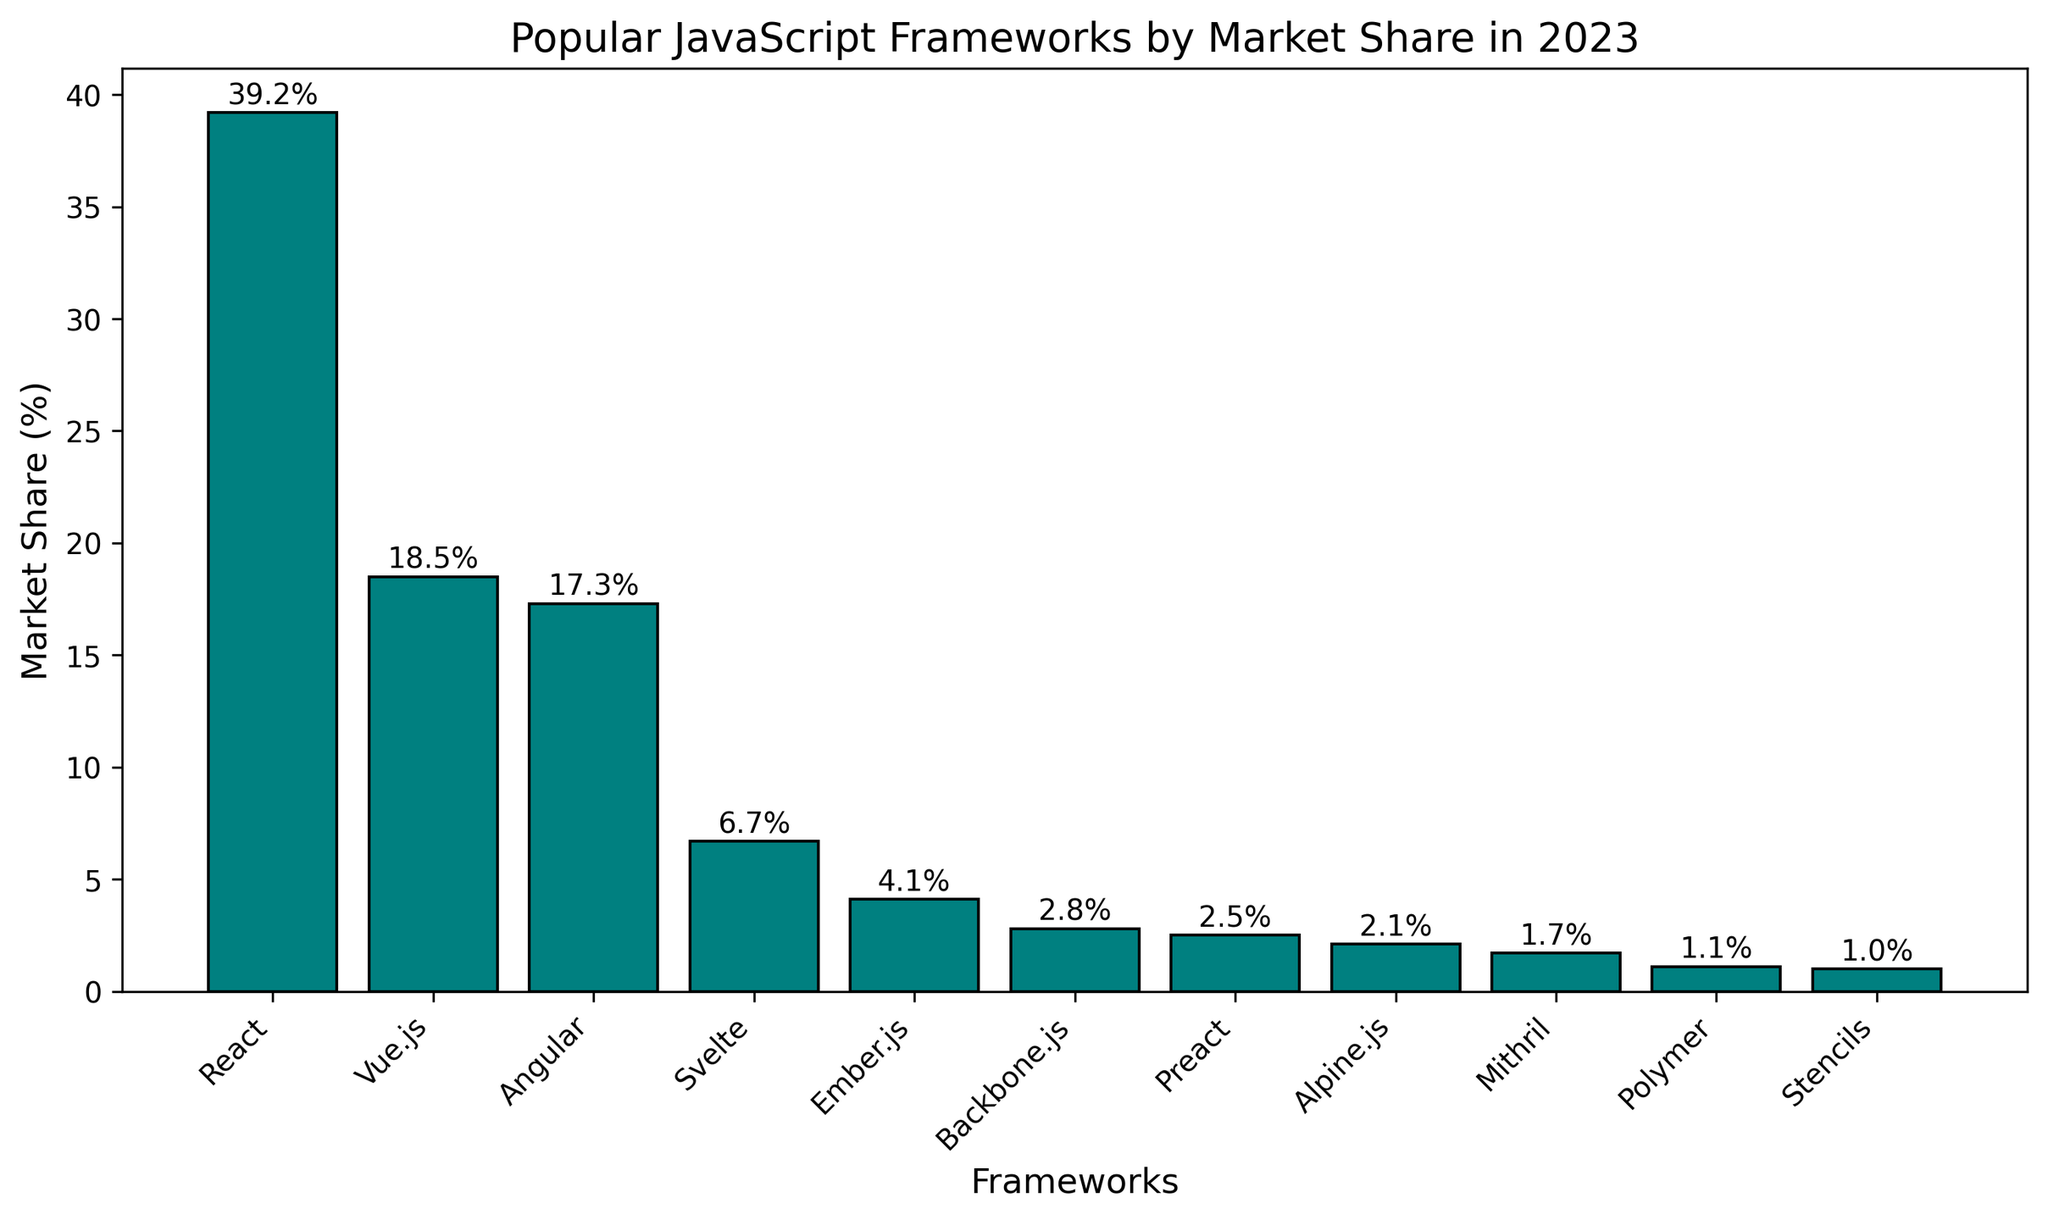What's the framework with the highest market share? The framework with the highest market share is the one with the tallest bar in the chart. By looking at the tops of each bar, we can see that React has the tallest bar.
Answer: React How much higher is React's market share compared to Angular? React's market share is 39.2%, and Angular's is 17.3%. To find out how much higher React's market share is, subtract Angular's share from React's. \(39.2 - 17.3 = 21.9\).
Answer: 21.9% What is the combined market share of Vue.js and Angular? To find the combined market share, add the market shares of Vue.js and Angular. \(18.5 + 17.3 = 35.8\).
Answer: 35.8% Which framework has a market share closest to 5%? By observing the heights of the bars, Svelte has a market share of 6.7%, which is the closest to 5%.
Answer: Svelte What is the average market share of the top 3 frameworks? The top 3 frameworks are React (39.2%), Vue.js (18.5%), and Angular (17.3%). To find the average, sum these values and divide by 3. \((39.2 + 18.5 + 17.3)/3 = 25.0\).
Answer: 25.0% Is Ember.js's market share greater than the sum of Preact and Alpine.js? Ember.js has a market share of 4.1%. Preact has 2.5% and Alpine.js has 2.1%. The sum of Preact and Alpine.js is \(2.5 + 2.1 = 4.6\). 4.1% is not greater than 4.6%.
Answer: No How much market share is held by frameworks with less than 5% share each? Frameworks with less than 5% share are Svelte (6.7%), Ember.js (4.1%), Backbone.js (2.8%), Preact (2.5%), Alpine.js (2.1%), Mithril (1.7%), Polymer (1.1%), and Stencils (1.0%). Adding the shares below 5%: \(4.1 + 2.8 + 2.5 + 2.1 + 1.7 + 1.1 + 1.0 = 15.3\).
Answer: 15.3% Among the frameworks with more than 10% market share, which one has the lowest? Frameworks with more than 10% share are React (39.2%), Vue.js (18.5%), and Angular (17.3%). Angular has the lowest share among these three.
Answer: Angular What is the difference in market share between the second and third most popular frameworks? The second most popular framework is Vue.js with 18.5%, and the third is Angular with 17.3%. The difference is \(18.5 - 17.3 = 1.2\).
Answer: 1.2% How many frameworks have a market share below 2%? By counting the bars with heights below 2%, we identify Mithril (1.7%), Polymer (1.1%), and Stencils (1.0%). So, there are 3 such frameworks.
Answer: 3 